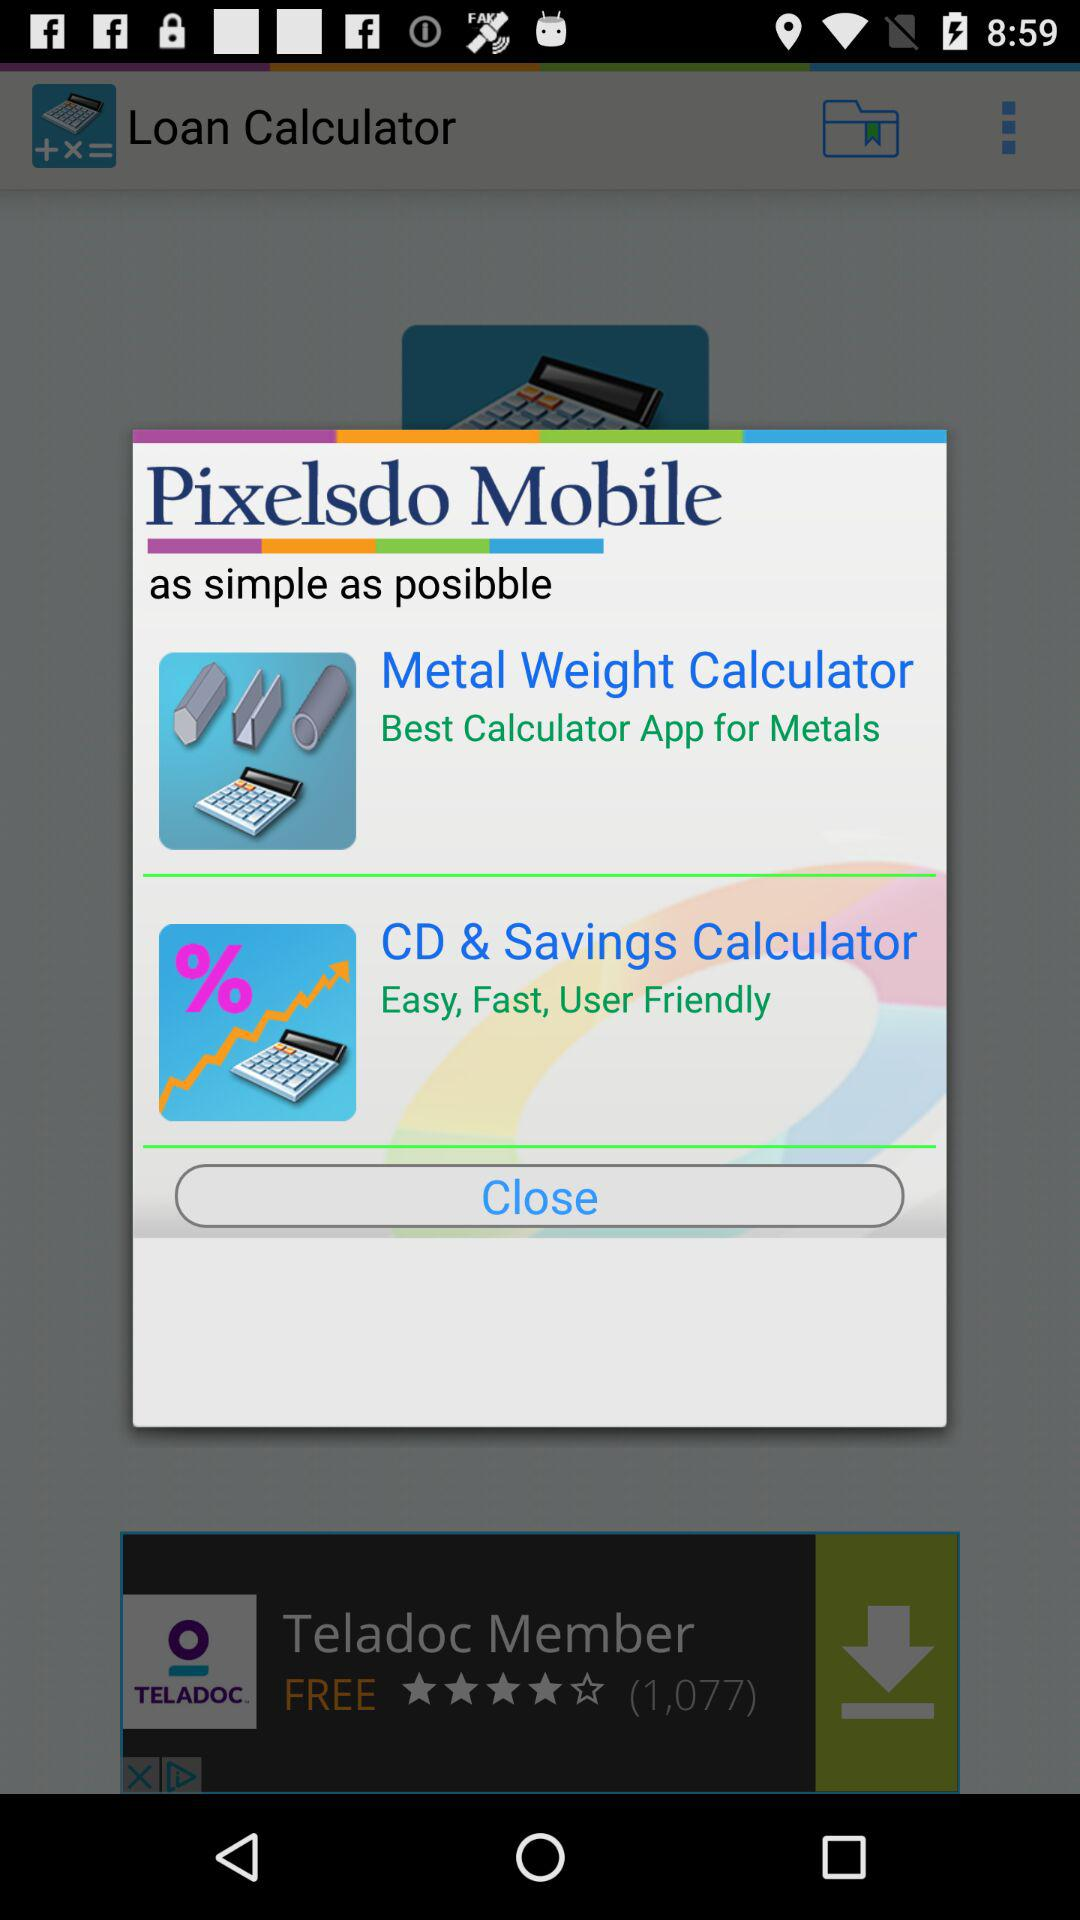What is the app name? The app names are "Loan Calculator", "Pixelsdo Mobile", "Metal Weight Calculator" and "CD & Savings Calculator". 